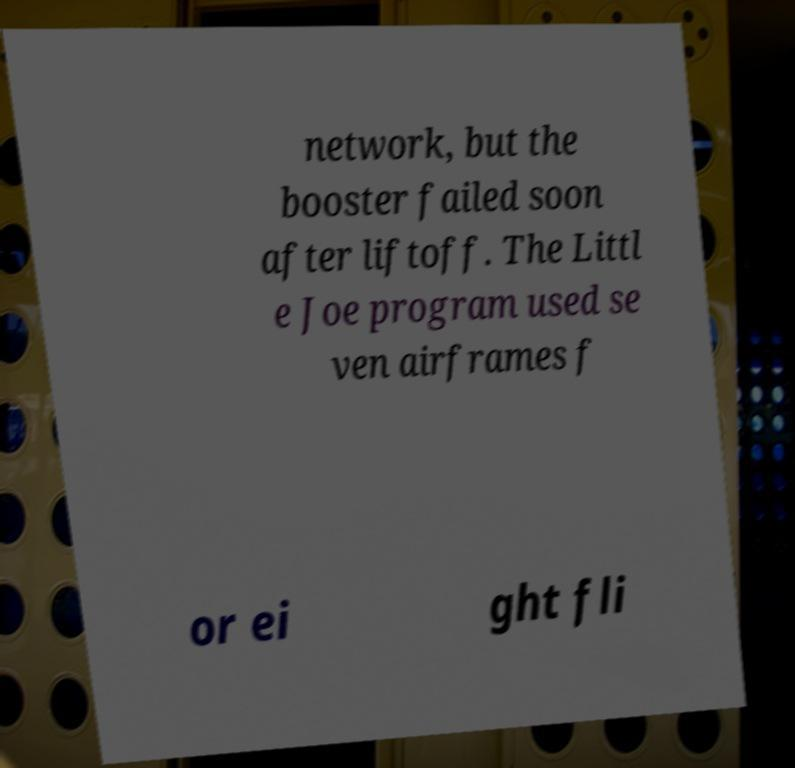Can you read and provide the text displayed in the image?This photo seems to have some interesting text. Can you extract and type it out for me? network, but the booster failed soon after liftoff. The Littl e Joe program used se ven airframes f or ei ght fli 